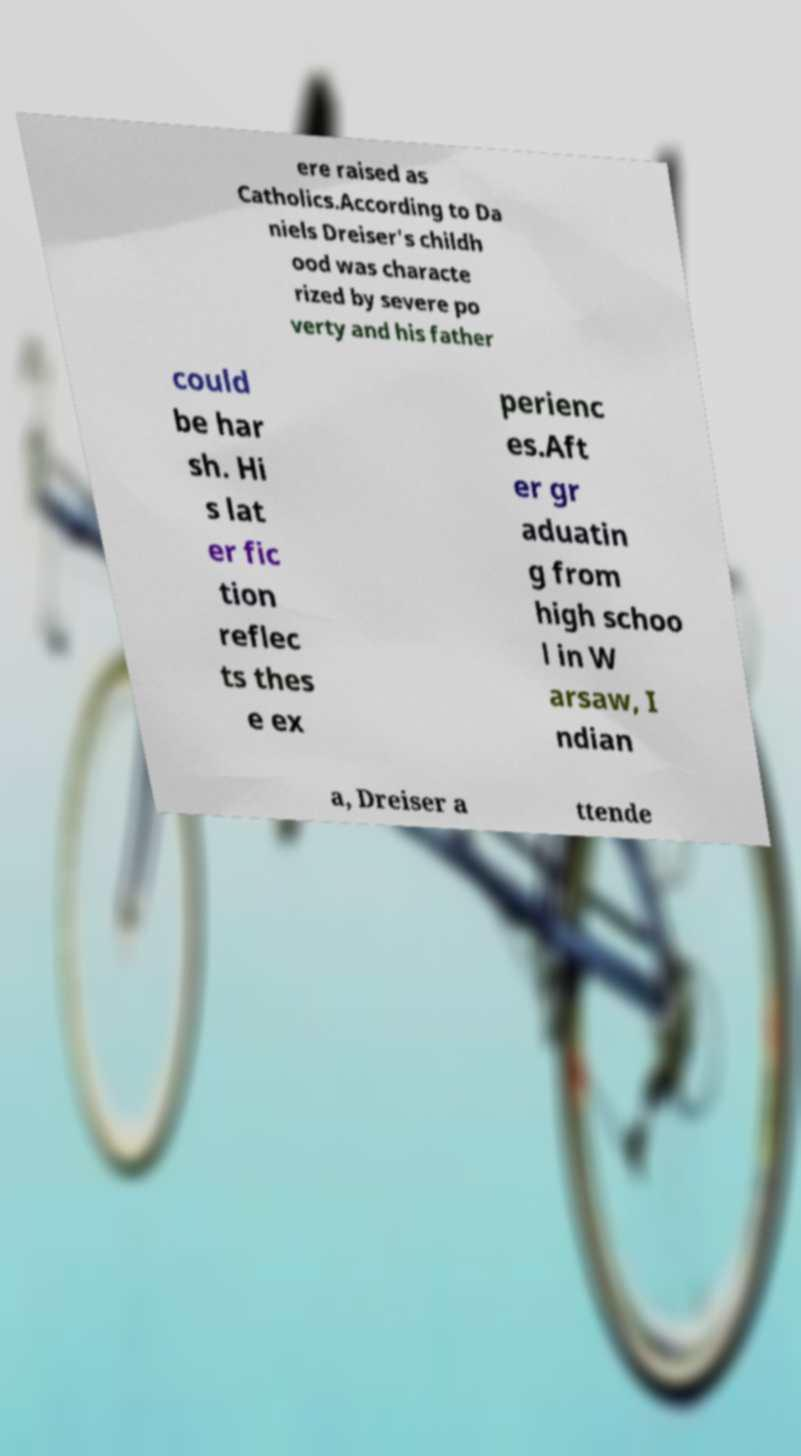For documentation purposes, I need the text within this image transcribed. Could you provide that? ere raised as Catholics.According to Da niels Dreiser's childh ood was characte rized by severe po verty and his father could be har sh. Hi s lat er fic tion reflec ts thes e ex perienc es.Aft er gr aduatin g from high schoo l in W arsaw, I ndian a, Dreiser a ttende 